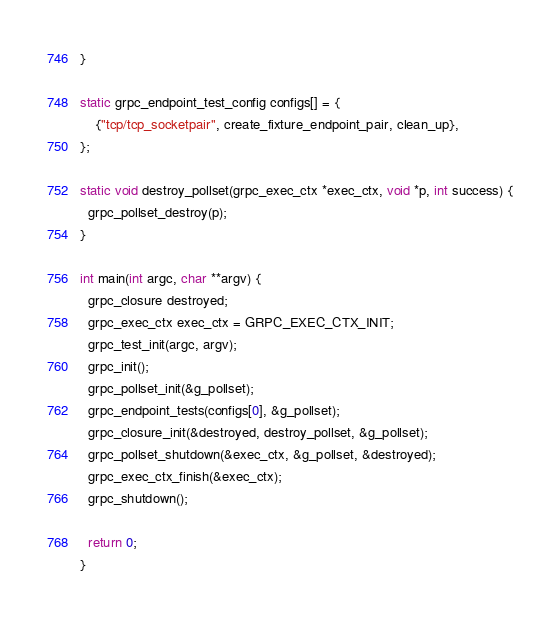<code> <loc_0><loc_0><loc_500><loc_500><_C_>}

static grpc_endpoint_test_config configs[] = {
    {"tcp/tcp_socketpair", create_fixture_endpoint_pair, clean_up},
};

static void destroy_pollset(grpc_exec_ctx *exec_ctx, void *p, int success) {
  grpc_pollset_destroy(p);
}

int main(int argc, char **argv) {
  grpc_closure destroyed;
  grpc_exec_ctx exec_ctx = GRPC_EXEC_CTX_INIT;
  grpc_test_init(argc, argv);
  grpc_init();
  grpc_pollset_init(&g_pollset);
  grpc_endpoint_tests(configs[0], &g_pollset);
  grpc_closure_init(&destroyed, destroy_pollset, &g_pollset);
  grpc_pollset_shutdown(&exec_ctx, &g_pollset, &destroyed);
  grpc_exec_ctx_finish(&exec_ctx);
  grpc_shutdown();

  return 0;
}
</code> 